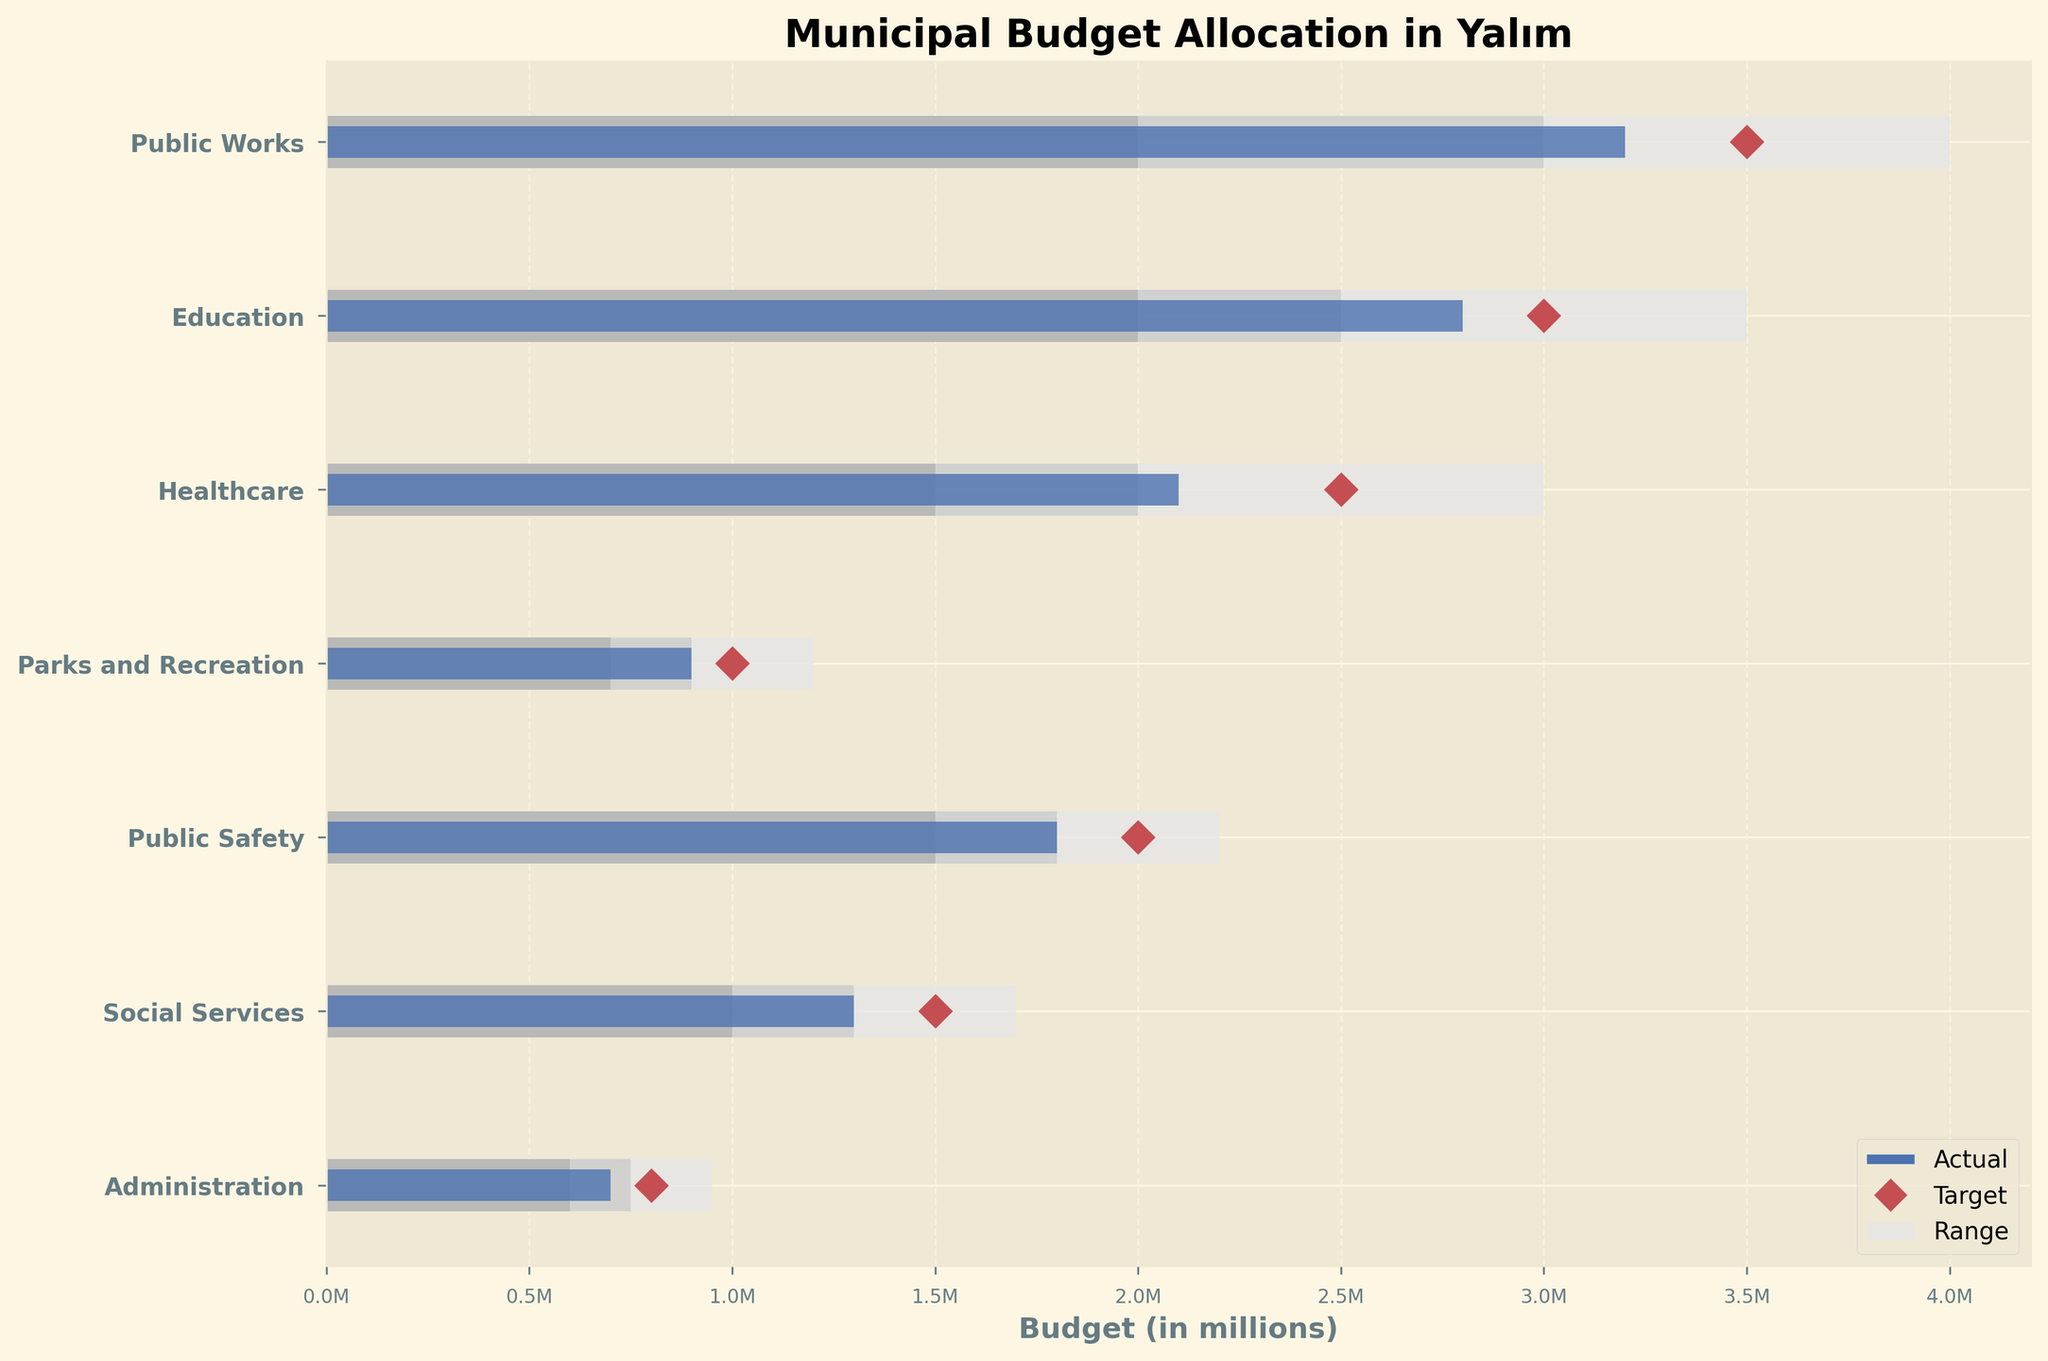What is the actual budget allocated to the Public Works department? By looking at the horizontal bar for Public Works, we can see the length of the blue bar representing the actual budget.
Answer: 3.2M What is the target budget for the Education department? The target budget for each department is marked by a red diamond on the plot. For Education, this diamond is located at 3,000,000.
Answer: 3.0M Which department has the largest actual budget? By comparing the lengths of the blue bars, the Public Works department has the longest bar, indicating the largest actual budget.
Answer: Public Works How far below the target is the budget for Healthcare? Healthcare actual budget is 2,100,000 and the target is 2,500,000. The difference is 2,500,000 - 2,100,000 = 400,000.
Answer: 400,000 Which departments have met or exceeded their target budgets? Look for departments where the blue bar reaches or surpasses the red diamond. Parks and Recreation, Social Services, and Administration have met or exceeded their targets.
Answer: Parks and Recreation, Social Services, Administration Compare the actual budgets of Public Safety and Social Services. Which one is higher? The blue bar of Public Safety represents 1.8M, while that of Social Services represents 1.3M. Public Safety is higher.
Answer: Public Safety What is the total budget range for the Administration department? The total range is shown by the grayscale bars. For Administration, this range is from 600,000 (start of the lightest bar) to 950,000 (end of the darkest bar).
Answer: 600,000 to 950,000 Is the actual budget for Public Works within the specified range? The actual budget for Public Works (3,200,000) falls within the range of 2,000,000 to 4,000,000.
Answer: Yes Which department's actual budget is closest to its target? By comparing the distances between blue bars and red diamonds for each department, Education's actual budget (2,800,000) closely matches its target (3,000,000), with a difference of 200,000.
Answer: Education 